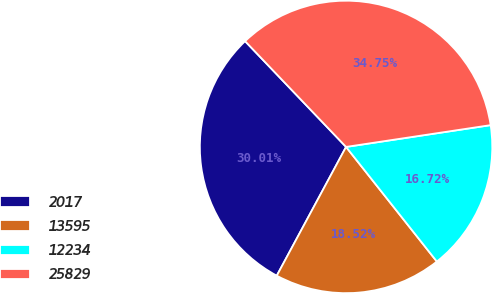Convert chart. <chart><loc_0><loc_0><loc_500><loc_500><pie_chart><fcel>2017<fcel>13595<fcel>12234<fcel>25829<nl><fcel>30.01%<fcel>18.52%<fcel>16.72%<fcel>34.75%<nl></chart> 